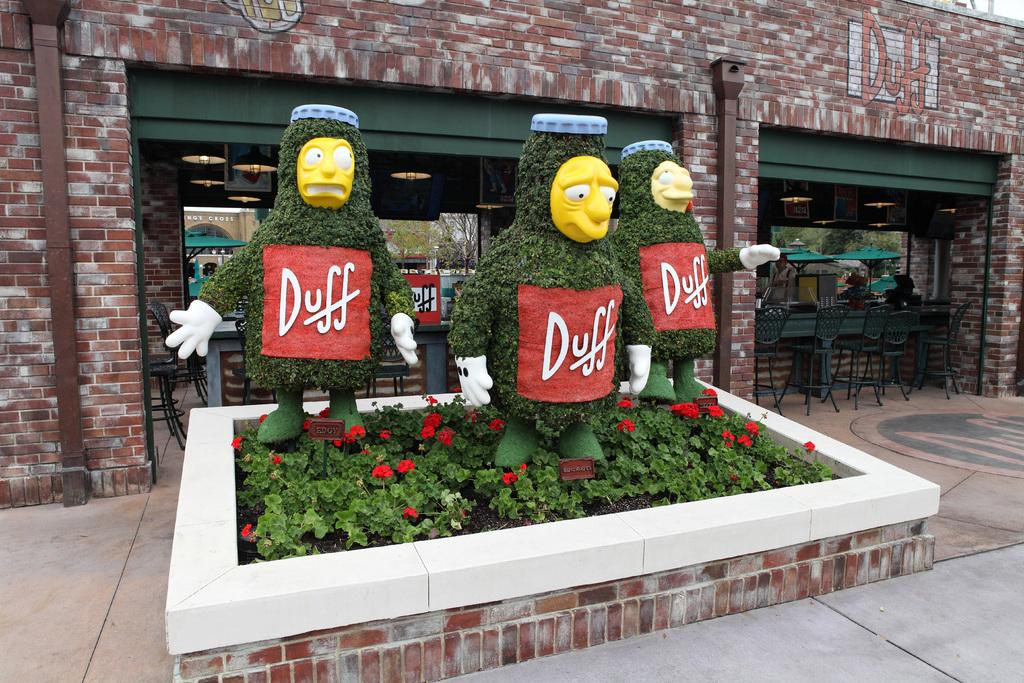<image>
Describe the image concisely. Three models of Simpsons characters with a red sticker that says Duff are standing above a garden. 